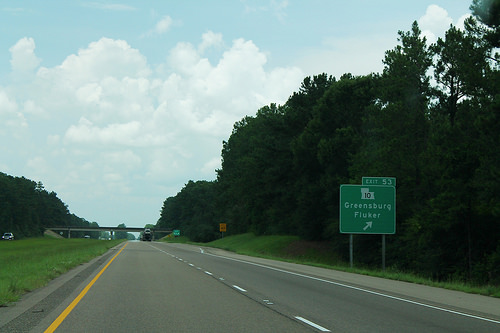<image>
Is there a sign on the road? No. The sign is not positioned on the road. They may be near each other, but the sign is not supported by or resting on top of the road. 